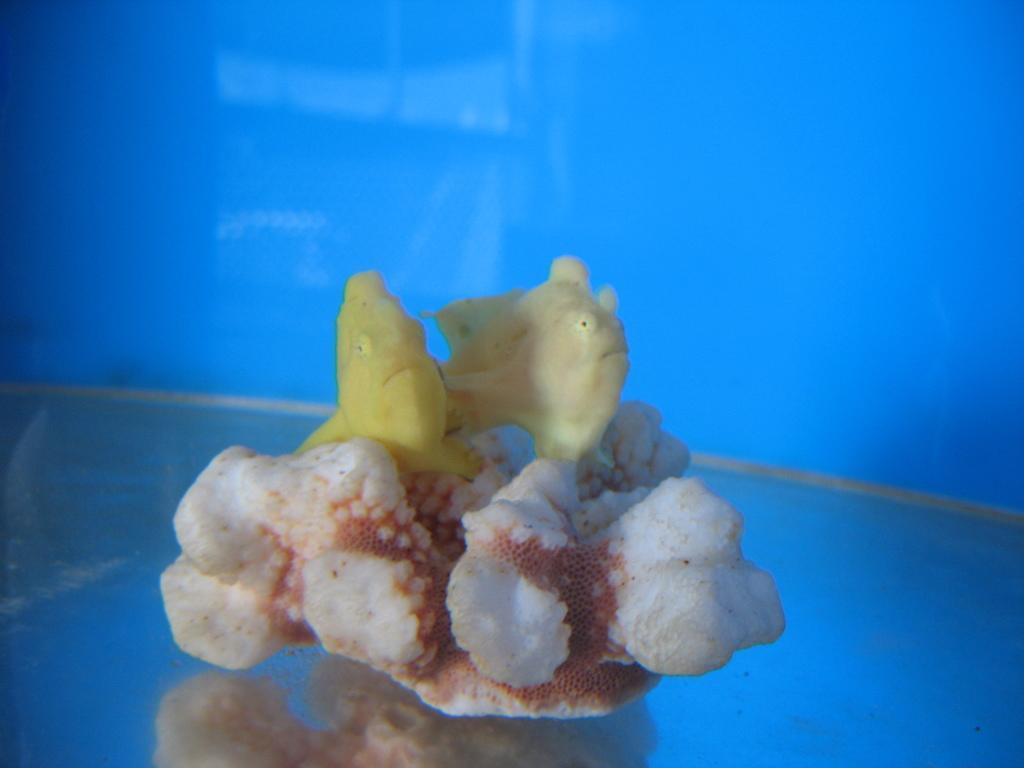Describe this image in one or two sentences. In the center of the image we can see one white and brown color object. On that object, we can see two fish, which are in yellow color. And we can see the blue color background. 